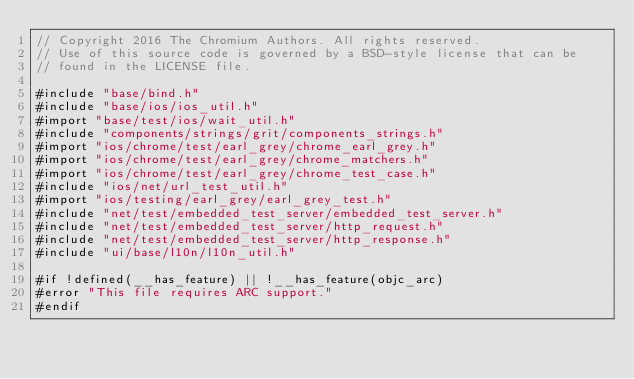<code> <loc_0><loc_0><loc_500><loc_500><_ObjectiveC_>// Copyright 2016 The Chromium Authors. All rights reserved.
// Use of this source code is governed by a BSD-style license that can be
// found in the LICENSE file.

#include "base/bind.h"
#include "base/ios/ios_util.h"
#import "base/test/ios/wait_util.h"
#include "components/strings/grit/components_strings.h"
#import "ios/chrome/test/earl_grey/chrome_earl_grey.h"
#import "ios/chrome/test/earl_grey/chrome_matchers.h"
#import "ios/chrome/test/earl_grey/chrome_test_case.h"
#include "ios/net/url_test_util.h"
#import "ios/testing/earl_grey/earl_grey_test.h"
#include "net/test/embedded_test_server/embedded_test_server.h"
#include "net/test/embedded_test_server/http_request.h"
#include "net/test/embedded_test_server/http_response.h"
#include "ui/base/l10n/l10n_util.h"

#if !defined(__has_feature) || !__has_feature(objc_arc)
#error "This file requires ARC support."
#endif
</code> 